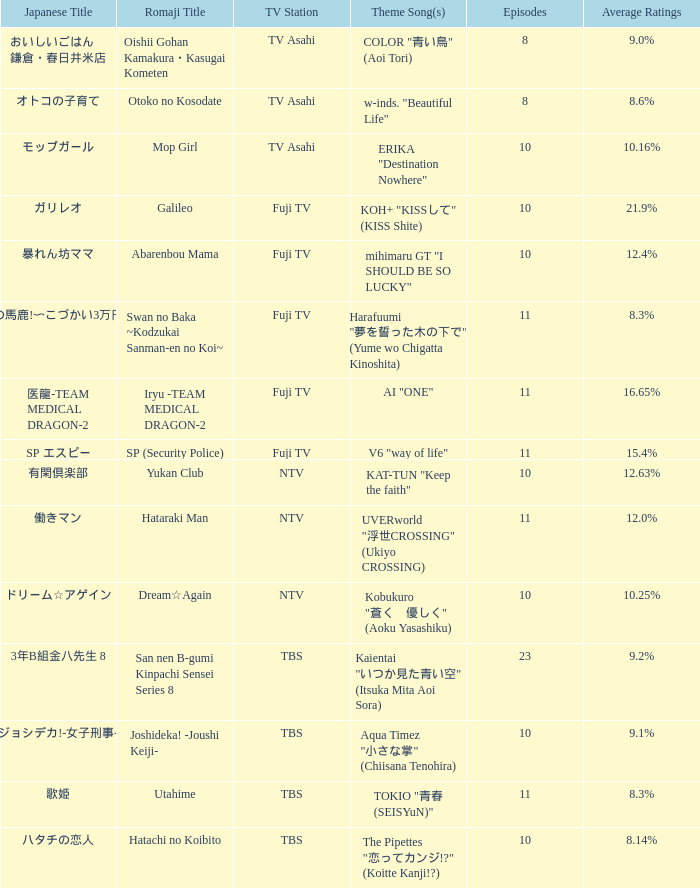Which episode features koh+'s "kiss shite" as its theme song? 10.0. 